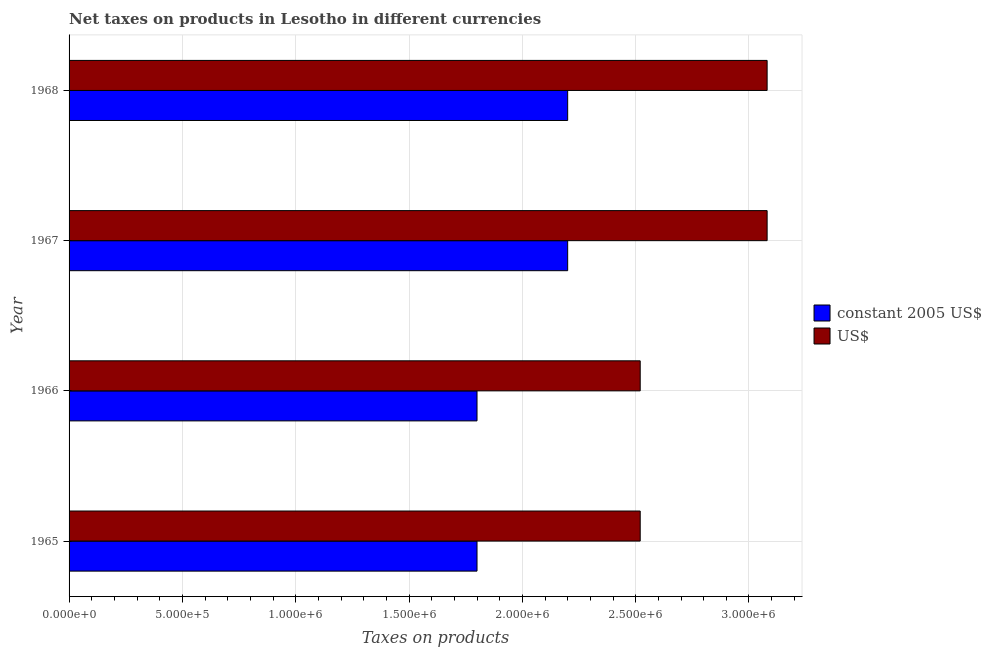How many different coloured bars are there?
Make the answer very short. 2. Are the number of bars per tick equal to the number of legend labels?
Provide a succinct answer. Yes. How many bars are there on the 2nd tick from the top?
Your response must be concise. 2. What is the label of the 1st group of bars from the top?
Provide a short and direct response. 1968. In how many cases, is the number of bars for a given year not equal to the number of legend labels?
Keep it short and to the point. 0. What is the net taxes in us$ in 1965?
Offer a very short reply. 2.52e+06. Across all years, what is the maximum net taxes in us$?
Your response must be concise. 3.08e+06. Across all years, what is the minimum net taxes in constant 2005 us$?
Make the answer very short. 1.80e+06. In which year was the net taxes in constant 2005 us$ maximum?
Your answer should be compact. 1967. In which year was the net taxes in constant 2005 us$ minimum?
Ensure brevity in your answer.  1965. What is the total net taxes in constant 2005 us$ in the graph?
Provide a short and direct response. 8.00e+06. What is the difference between the net taxes in us$ in 1966 and that in 1968?
Your answer should be compact. -5.60e+05. What is the difference between the net taxes in constant 2005 us$ in 1967 and the net taxes in us$ in 1966?
Offer a terse response. -3.20e+05. What is the average net taxes in constant 2005 us$ per year?
Ensure brevity in your answer.  2.00e+06. In the year 1967, what is the difference between the net taxes in constant 2005 us$ and net taxes in us$?
Offer a very short reply. -8.80e+05. In how many years, is the net taxes in constant 2005 us$ greater than 700000 units?
Ensure brevity in your answer.  4. What is the ratio of the net taxes in us$ in 1965 to that in 1967?
Offer a terse response. 0.82. Is the net taxes in us$ in 1966 less than that in 1967?
Your response must be concise. Yes. Is the difference between the net taxes in constant 2005 us$ in 1965 and 1967 greater than the difference between the net taxes in us$ in 1965 and 1967?
Your answer should be compact. Yes. What is the difference between the highest and the second highest net taxes in constant 2005 us$?
Provide a short and direct response. 0. What is the difference between the highest and the lowest net taxes in us$?
Keep it short and to the point. 5.60e+05. In how many years, is the net taxes in us$ greater than the average net taxes in us$ taken over all years?
Give a very brief answer. 2. Is the sum of the net taxes in us$ in 1966 and 1967 greater than the maximum net taxes in constant 2005 us$ across all years?
Your response must be concise. Yes. What does the 2nd bar from the top in 1965 represents?
Your answer should be compact. Constant 2005 us$. What does the 1st bar from the bottom in 1967 represents?
Provide a succinct answer. Constant 2005 us$. How many bars are there?
Provide a succinct answer. 8. Are all the bars in the graph horizontal?
Your answer should be very brief. Yes. How many years are there in the graph?
Keep it short and to the point. 4. Where does the legend appear in the graph?
Your answer should be compact. Center right. What is the title of the graph?
Your response must be concise. Net taxes on products in Lesotho in different currencies. What is the label or title of the X-axis?
Your answer should be very brief. Taxes on products. What is the Taxes on products in constant 2005 US$ in 1965?
Provide a short and direct response. 1.80e+06. What is the Taxes on products of US$ in 1965?
Provide a succinct answer. 2.52e+06. What is the Taxes on products in constant 2005 US$ in 1966?
Make the answer very short. 1.80e+06. What is the Taxes on products in US$ in 1966?
Offer a very short reply. 2.52e+06. What is the Taxes on products of constant 2005 US$ in 1967?
Make the answer very short. 2.20e+06. What is the Taxes on products in US$ in 1967?
Your response must be concise. 3.08e+06. What is the Taxes on products in constant 2005 US$ in 1968?
Offer a very short reply. 2.20e+06. What is the Taxes on products of US$ in 1968?
Provide a short and direct response. 3.08e+06. Across all years, what is the maximum Taxes on products of constant 2005 US$?
Offer a very short reply. 2.20e+06. Across all years, what is the maximum Taxes on products of US$?
Make the answer very short. 3.08e+06. Across all years, what is the minimum Taxes on products in constant 2005 US$?
Ensure brevity in your answer.  1.80e+06. Across all years, what is the minimum Taxes on products in US$?
Your response must be concise. 2.52e+06. What is the total Taxes on products of US$ in the graph?
Keep it short and to the point. 1.12e+07. What is the difference between the Taxes on products in US$ in 1965 and that in 1966?
Your answer should be very brief. 0. What is the difference between the Taxes on products in constant 2005 US$ in 1965 and that in 1967?
Offer a very short reply. -4.00e+05. What is the difference between the Taxes on products of US$ in 1965 and that in 1967?
Offer a very short reply. -5.60e+05. What is the difference between the Taxes on products of constant 2005 US$ in 1965 and that in 1968?
Your answer should be very brief. -4.00e+05. What is the difference between the Taxes on products in US$ in 1965 and that in 1968?
Offer a very short reply. -5.60e+05. What is the difference between the Taxes on products in constant 2005 US$ in 1966 and that in 1967?
Provide a short and direct response. -4.00e+05. What is the difference between the Taxes on products in US$ in 1966 and that in 1967?
Give a very brief answer. -5.60e+05. What is the difference between the Taxes on products in constant 2005 US$ in 1966 and that in 1968?
Your response must be concise. -4.00e+05. What is the difference between the Taxes on products in US$ in 1966 and that in 1968?
Your answer should be very brief. -5.60e+05. What is the difference between the Taxes on products of constant 2005 US$ in 1967 and that in 1968?
Your response must be concise. 0. What is the difference between the Taxes on products in US$ in 1967 and that in 1968?
Provide a succinct answer. 0. What is the difference between the Taxes on products in constant 2005 US$ in 1965 and the Taxes on products in US$ in 1966?
Ensure brevity in your answer.  -7.20e+05. What is the difference between the Taxes on products in constant 2005 US$ in 1965 and the Taxes on products in US$ in 1967?
Offer a terse response. -1.28e+06. What is the difference between the Taxes on products of constant 2005 US$ in 1965 and the Taxes on products of US$ in 1968?
Keep it short and to the point. -1.28e+06. What is the difference between the Taxes on products in constant 2005 US$ in 1966 and the Taxes on products in US$ in 1967?
Your response must be concise. -1.28e+06. What is the difference between the Taxes on products of constant 2005 US$ in 1966 and the Taxes on products of US$ in 1968?
Make the answer very short. -1.28e+06. What is the difference between the Taxes on products in constant 2005 US$ in 1967 and the Taxes on products in US$ in 1968?
Offer a very short reply. -8.80e+05. What is the average Taxes on products of constant 2005 US$ per year?
Your answer should be very brief. 2.00e+06. What is the average Taxes on products of US$ per year?
Ensure brevity in your answer.  2.80e+06. In the year 1965, what is the difference between the Taxes on products in constant 2005 US$ and Taxes on products in US$?
Provide a short and direct response. -7.20e+05. In the year 1966, what is the difference between the Taxes on products of constant 2005 US$ and Taxes on products of US$?
Provide a succinct answer. -7.20e+05. In the year 1967, what is the difference between the Taxes on products of constant 2005 US$ and Taxes on products of US$?
Your answer should be very brief. -8.80e+05. In the year 1968, what is the difference between the Taxes on products of constant 2005 US$ and Taxes on products of US$?
Offer a terse response. -8.80e+05. What is the ratio of the Taxes on products of constant 2005 US$ in 1965 to that in 1966?
Your response must be concise. 1. What is the ratio of the Taxes on products in US$ in 1965 to that in 1966?
Your answer should be very brief. 1. What is the ratio of the Taxes on products in constant 2005 US$ in 1965 to that in 1967?
Your answer should be compact. 0.82. What is the ratio of the Taxes on products of US$ in 1965 to that in 1967?
Give a very brief answer. 0.82. What is the ratio of the Taxes on products of constant 2005 US$ in 1965 to that in 1968?
Make the answer very short. 0.82. What is the ratio of the Taxes on products in US$ in 1965 to that in 1968?
Keep it short and to the point. 0.82. What is the ratio of the Taxes on products of constant 2005 US$ in 1966 to that in 1967?
Your answer should be very brief. 0.82. What is the ratio of the Taxes on products of US$ in 1966 to that in 1967?
Your response must be concise. 0.82. What is the ratio of the Taxes on products in constant 2005 US$ in 1966 to that in 1968?
Offer a very short reply. 0.82. What is the ratio of the Taxes on products of US$ in 1966 to that in 1968?
Offer a terse response. 0.82. What is the difference between the highest and the second highest Taxes on products in US$?
Your answer should be very brief. 0. What is the difference between the highest and the lowest Taxes on products of constant 2005 US$?
Provide a succinct answer. 4.00e+05. What is the difference between the highest and the lowest Taxes on products in US$?
Offer a very short reply. 5.60e+05. 